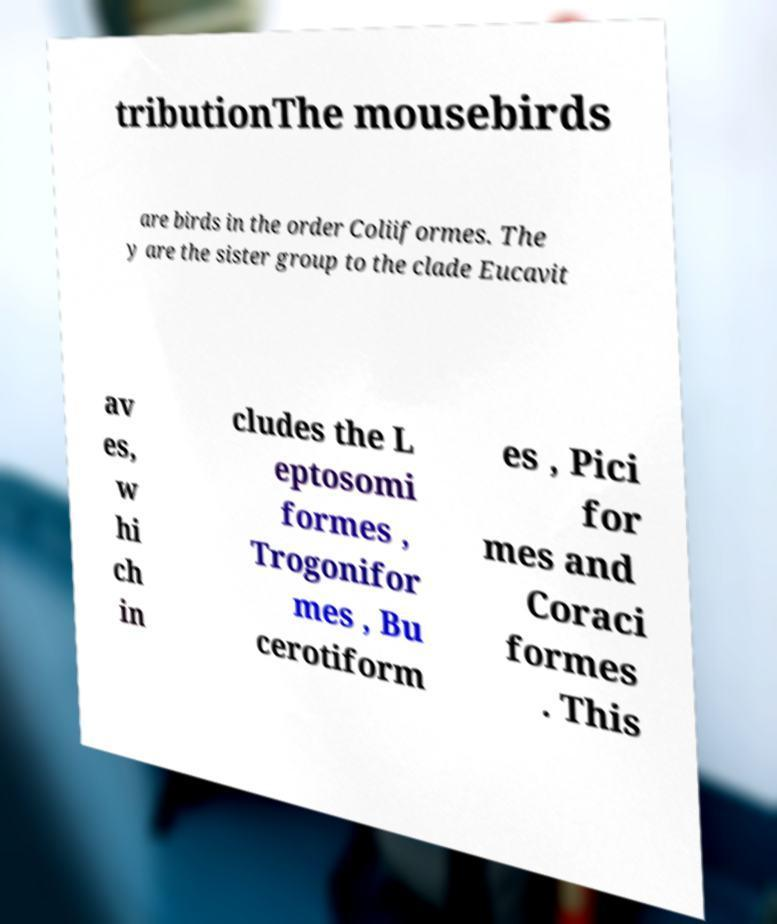What messages or text are displayed in this image? I need them in a readable, typed format. tributionThe mousebirds are birds in the order Coliiformes. The y are the sister group to the clade Eucavit av es, w hi ch in cludes the L eptosomi formes , Trogonifor mes , Bu cerotiform es , Pici for mes and Coraci formes . This 